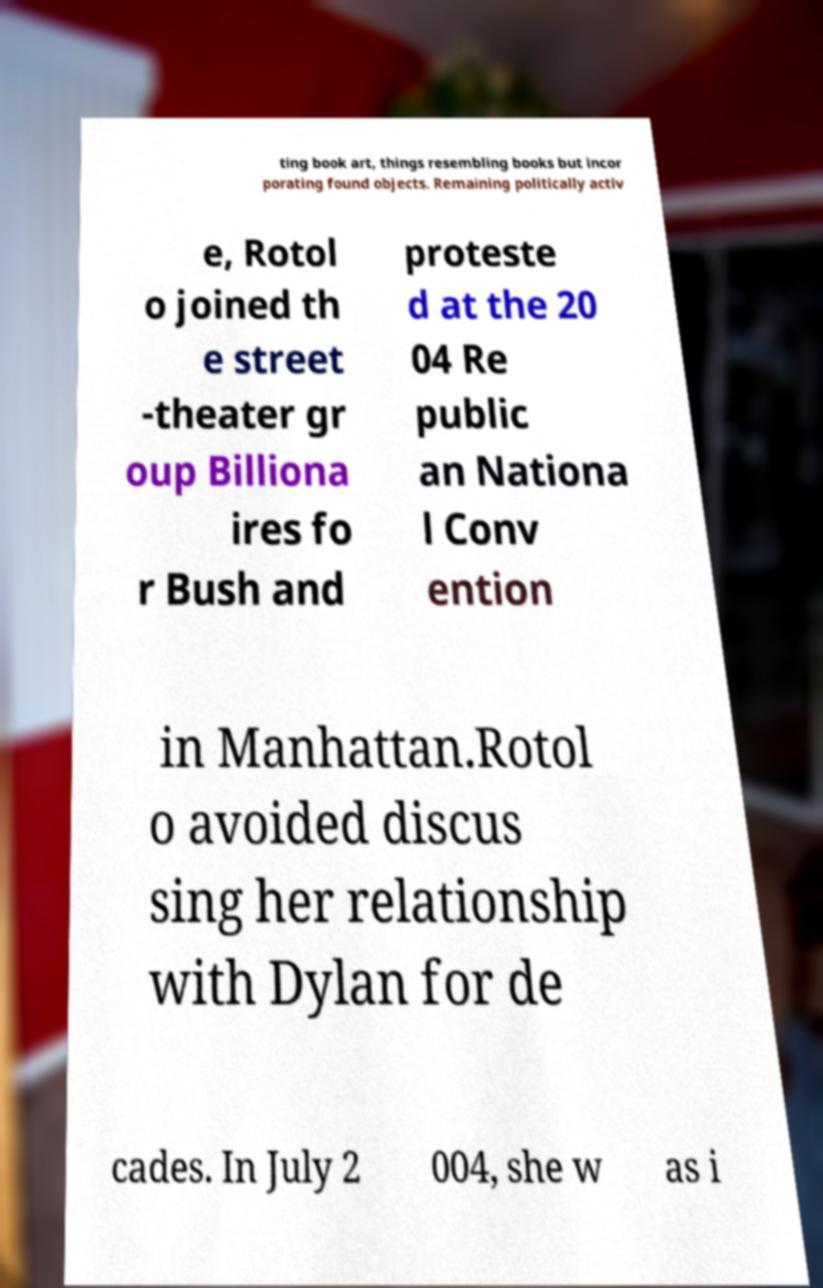What messages or text are displayed in this image? I need them in a readable, typed format. ting book art, things resembling books but incor porating found objects. Remaining politically activ e, Rotol o joined th e street -theater gr oup Billiona ires fo r Bush and proteste d at the 20 04 Re public an Nationa l Conv ention in Manhattan.Rotol o avoided discus sing her relationship with Dylan for de cades. In July 2 004, she w as i 